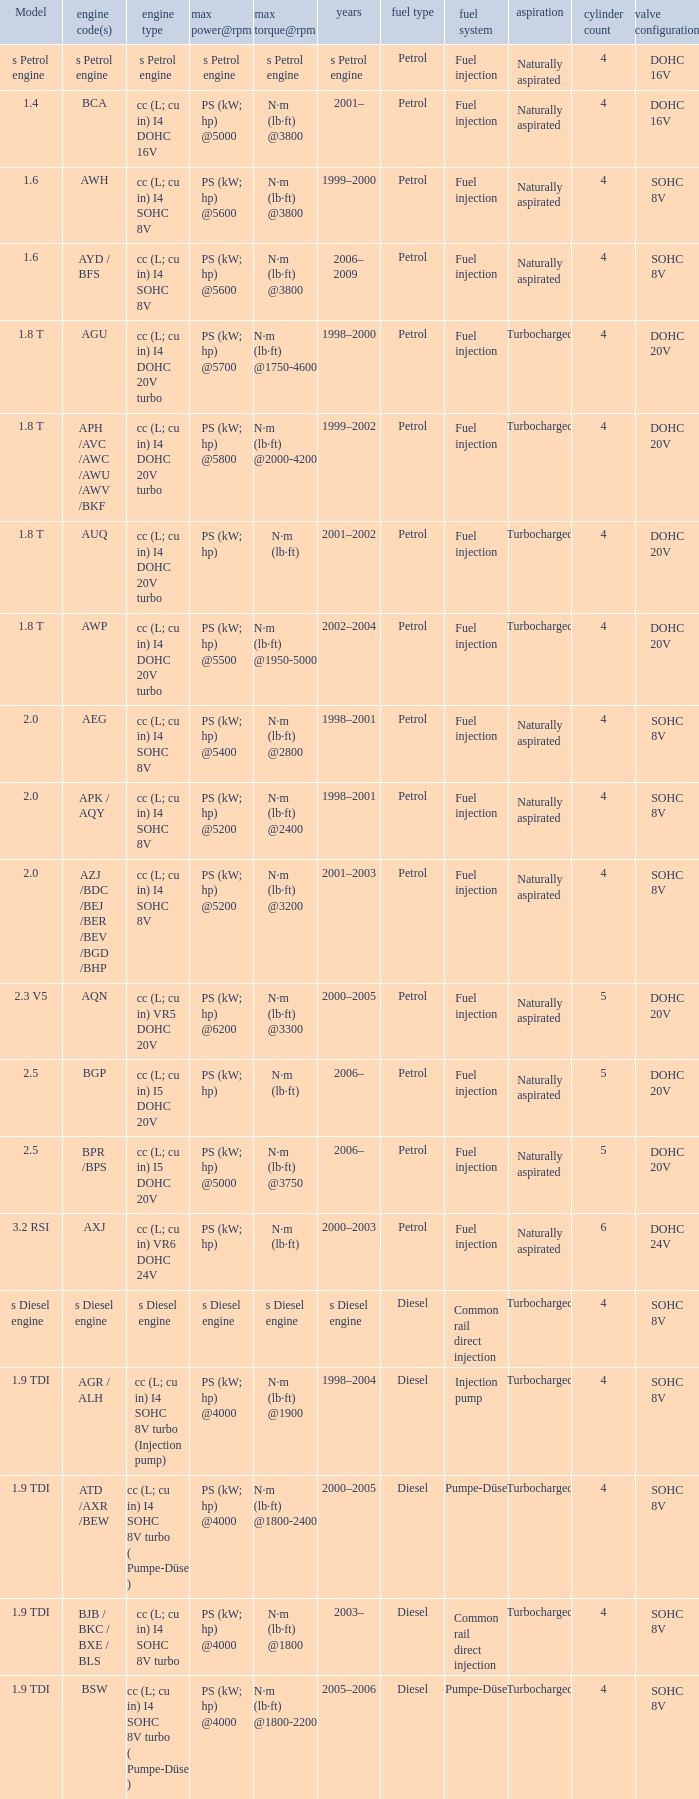Which engine type was used in the model 2.3 v5? Cc (l; cu in) vr5 dohc 20v. 